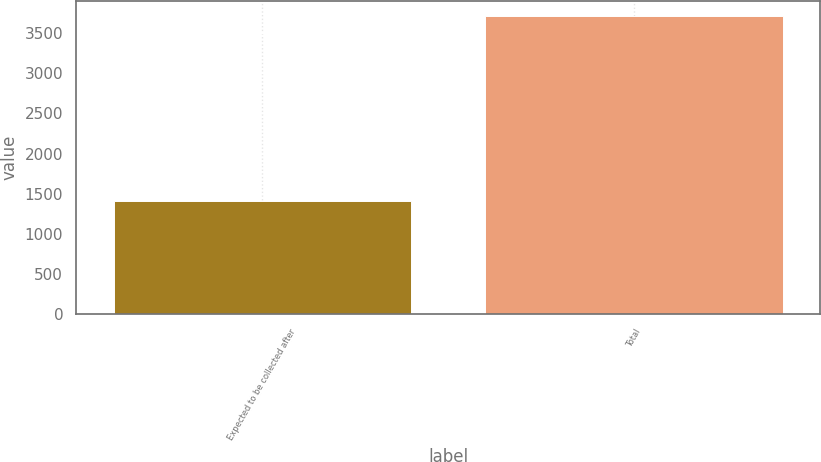Convert chart to OTSL. <chart><loc_0><loc_0><loc_500><loc_500><bar_chart><fcel>Expected to be collected after<fcel>Total<nl><fcel>1408<fcel>3714<nl></chart> 